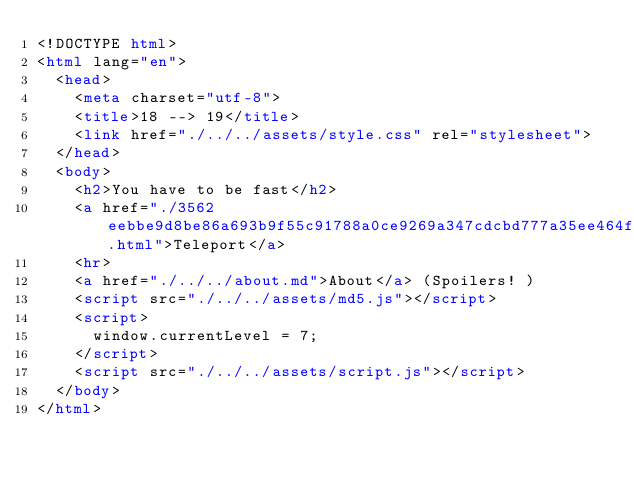<code> <loc_0><loc_0><loc_500><loc_500><_HTML_><!DOCTYPE html>
<html lang="en">
  <head>
    <meta charset="utf-8">
    <title>18 --> 19</title>
    <link href="./../../assets/style.css" rel="stylesheet">
  </head>
  <body>
    <h2>You have to be fast</h2>
    <a href="./3562eebbe9d8be86a693b9f55c91788a0ce9269a347cdcbd777a35ee464ff5c5.html">Teleport</a>
    <hr>
    <a href="./../../about.md">About</a> (Spoilers! )
    <script src="./../../assets/md5.js"></script>
    <script>
      window.currentLevel = 7;
    </script>
    <script src="./../../assets/script.js"></script>
  </body>
</html></code> 